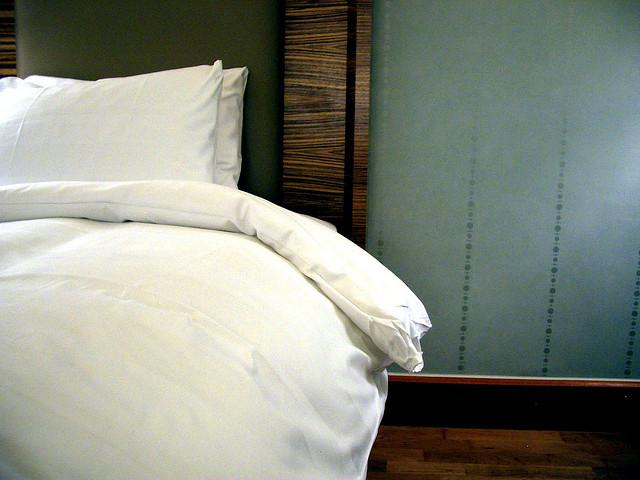What is the headboard made of?
Quick response, please. Wood. Is the bed made?
Give a very brief answer. Yes. Is this a hotel?
Keep it brief. No. 